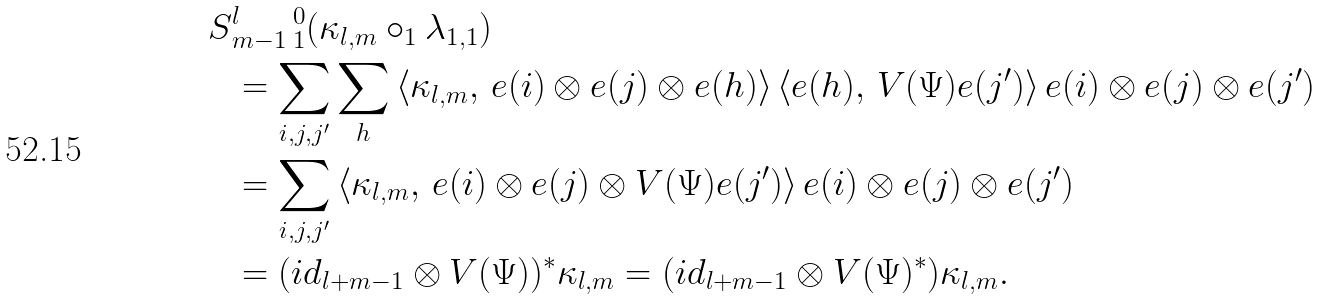<formula> <loc_0><loc_0><loc_500><loc_500>S & _ { m - 1 } ^ { l } \, _ { 1 } ^ { 0 } ( \kappa _ { l , m } \circ _ { 1 } \lambda _ { 1 , 1 } ) \\ & = \sum _ { i , j , j ^ { \prime } } \sum _ { h } \left \langle \kappa _ { l , m } , \, e ( i ) \otimes e ( j ) \otimes e ( h ) \right \rangle \left \langle e ( h ) , \, V ( \Psi ) e ( j ^ { \prime } ) \right \rangle e ( i ) \otimes e ( j ) \otimes e ( j ^ { \prime } ) \\ & = \sum _ { i , j , j ^ { \prime } } \left \langle \kappa _ { l , m } , \, e ( i ) \otimes e ( j ) \otimes V ( \Psi ) e ( j ^ { \prime } ) \right \rangle e ( i ) \otimes e ( j ) \otimes e ( j ^ { \prime } ) \\ & = ( i d _ { l + m - 1 } \otimes V ( \Psi ) ) ^ { * } \kappa _ { l , m } = ( i d _ { l + m - 1 } \otimes V ( \Psi ) ^ { * } ) \kappa _ { l , m } .</formula> 